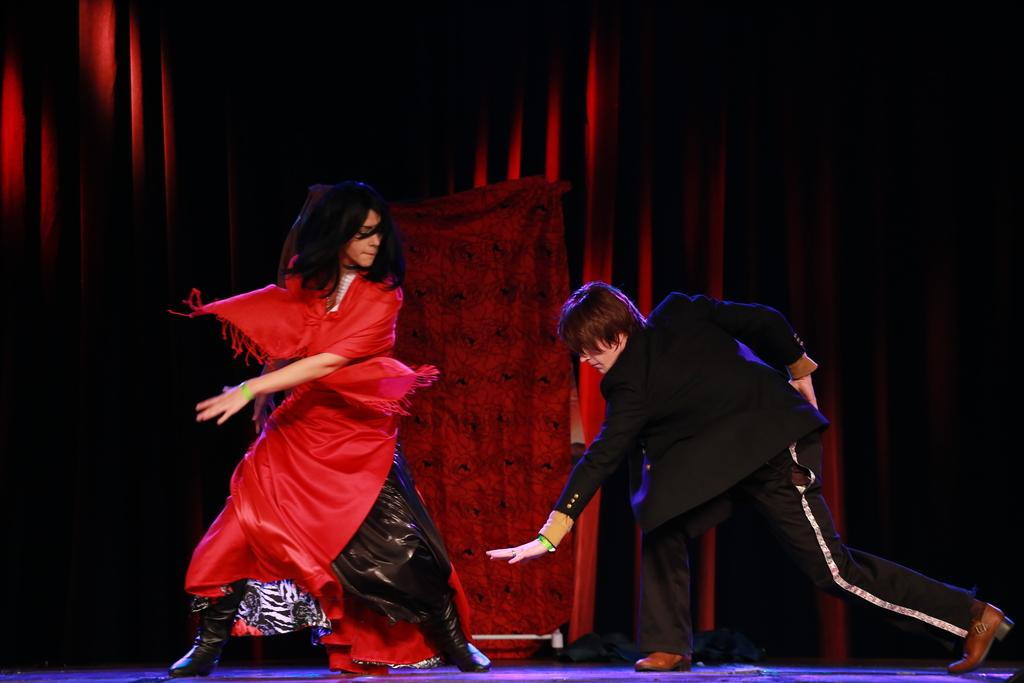Who or what can be seen in the image? There are people in the image. What are the people wearing? The people are wearing costumes. Where are the people located in the image? The people are on a stage. What can be seen in the background of the image? There is a curtain and a cloth visible in the background. How many harbors can be seen in the image? There are no harbors present in the image. What type of guide is assisting the people on stage? There is no guide present in the image; the people are on stage without assistance. 